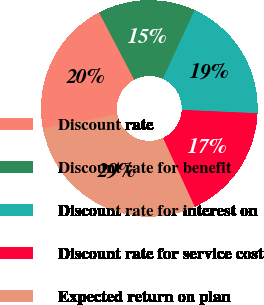<chart> <loc_0><loc_0><loc_500><loc_500><pie_chart><fcel>Discount rate<fcel>Discount rate for benefit<fcel>Discount rate for interest on<fcel>Discount rate for service cost<fcel>Expected return on plan<nl><fcel>20.27%<fcel>14.55%<fcel>18.84%<fcel>17.41%<fcel>28.93%<nl></chart> 